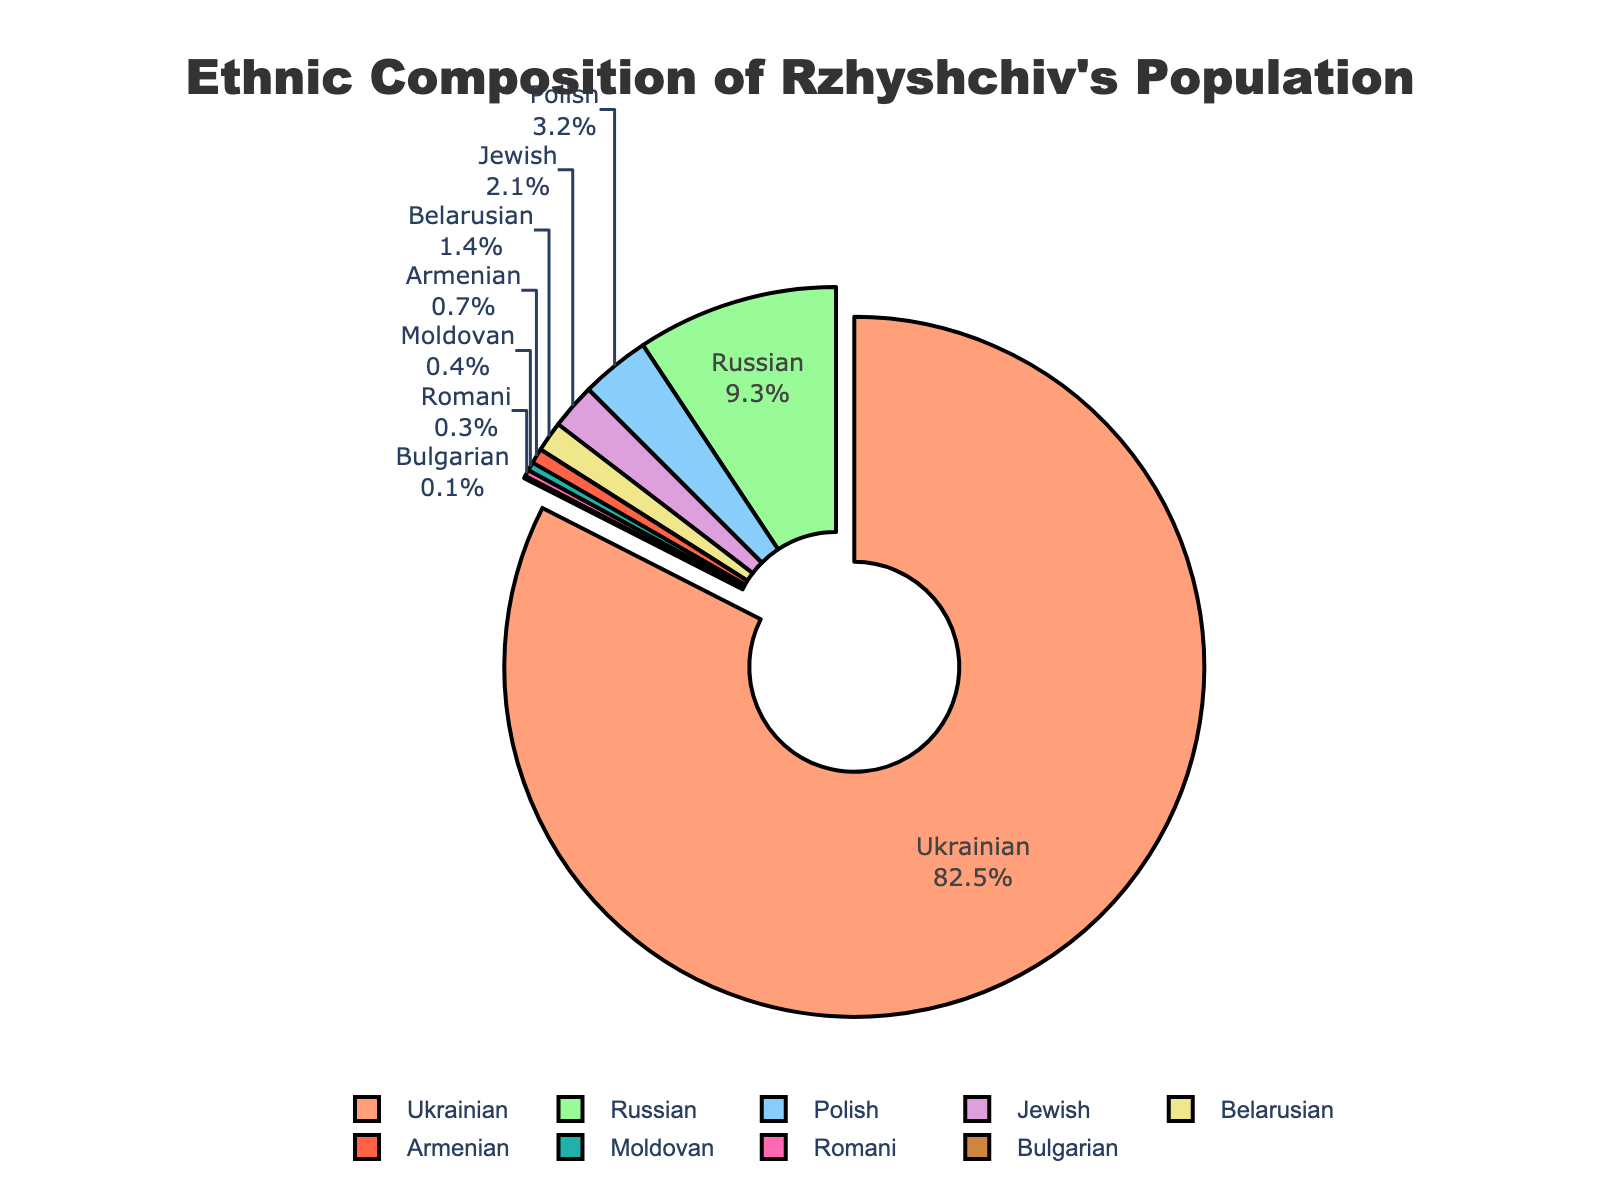What is the largest ethnic group in Rzhyshchiv's population? The largest ethnic group is represented by the biggest segment in the pie chart, which is also slightly pulled out from the rest. This segment is labeled as "Ukrainian" with 82.5%.
Answer: Ukrainian What is the combined percentage of the Polish and Jewish ethnicities? To find this, add the percentages of Polish and Jewish ethnicities. Polish have 3.2% and Jewish have 2.1%. Adding them: 3.2 + 2.1 = 5.3%.
Answer: 5.3% Which ethnic group has the smallest representation in Rzhyshchiv? The smallest segment in the pie chart corresponds to the Bulgarian ethnicity, which is labeled with 0.1%.
Answer: Bulgarian How does the percentage of Russians compare to the percentage of Belarusians? The percentage of Russians is 9.3%, while that of Belarusians is 1.4%. Comparing these, Russians have a higher percentage.
Answer: Russians have a higher percentage What is the total percentage of all ethnic groups other than Ukrainians? Subtract the percentage of Ukrainians from 100% to find the combined percentage of all other groups: 100 - 82.5 = 17.5%.
Answer: 17.5% Which ethnic group is represented with a green color in the pie chart? The legend indicates that the green-colored segment is labeled as "Russian" with 9.3%.
Answer: Russian If you combine the percentages of the Jewish and Armenian populations, is it greater than the percentage of the Russian population? Add the percentages of Jewish (2.1%) and Armenian (0.7%) to see if their sum is greater than that of Russians (9.3%): 2.1 + 0.7 = 2.8%, which is less than 9.3%.
Answer: No What is the percentage difference between the Ukrainian and Russian populations? Subtract the percentage of Russians from that of Ukrainians: 82.5 - 9.3 = 73.2%.
Answer: 73.2% Which ethnicities, if any, have a representation below 1%? The ethnicities with percentages below 1% are Armenian (0.7%), Moldovan (0.4%), Romani (0.3%), and Bulgarian (0.1%).
Answer: Armenian, Moldovan, Romani, Bulgarian How many ethnic groups have percentages greater than or equal to 3%? From the chart, the ethnic groups with percentages greater than or equal to 3% are Ukrainian (82.5%), Russian (9.3%), and Polish (3.2%). That makes three ethnic groups.
Answer: Three 